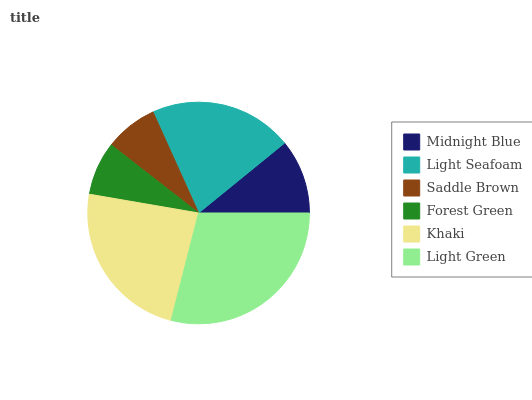Is Saddle Brown the minimum?
Answer yes or no. Yes. Is Light Green the maximum?
Answer yes or no. Yes. Is Light Seafoam the minimum?
Answer yes or no. No. Is Light Seafoam the maximum?
Answer yes or no. No. Is Light Seafoam greater than Midnight Blue?
Answer yes or no. Yes. Is Midnight Blue less than Light Seafoam?
Answer yes or no. Yes. Is Midnight Blue greater than Light Seafoam?
Answer yes or no. No. Is Light Seafoam less than Midnight Blue?
Answer yes or no. No. Is Light Seafoam the high median?
Answer yes or no. Yes. Is Midnight Blue the low median?
Answer yes or no. Yes. Is Forest Green the high median?
Answer yes or no. No. Is Light Seafoam the low median?
Answer yes or no. No. 